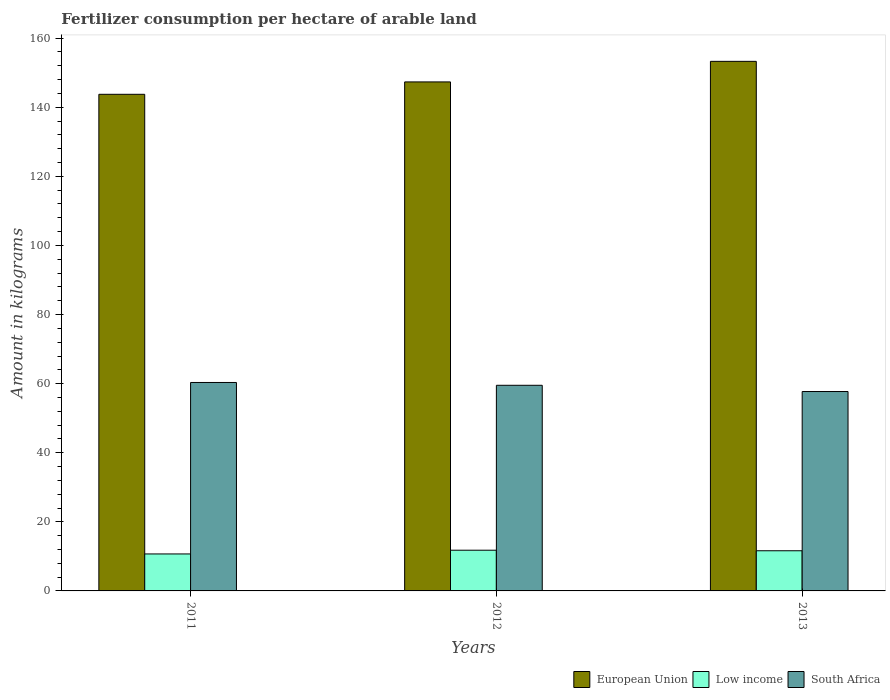Are the number of bars per tick equal to the number of legend labels?
Make the answer very short. Yes. Are the number of bars on each tick of the X-axis equal?
Offer a terse response. Yes. How many bars are there on the 1st tick from the left?
Provide a short and direct response. 3. How many bars are there on the 1st tick from the right?
Your response must be concise. 3. What is the label of the 2nd group of bars from the left?
Ensure brevity in your answer.  2012. In how many cases, is the number of bars for a given year not equal to the number of legend labels?
Ensure brevity in your answer.  0. What is the amount of fertilizer consumption in European Union in 2013?
Provide a short and direct response. 153.29. Across all years, what is the maximum amount of fertilizer consumption in Low income?
Offer a very short reply. 11.78. Across all years, what is the minimum amount of fertilizer consumption in South Africa?
Ensure brevity in your answer.  57.72. What is the total amount of fertilizer consumption in South Africa in the graph?
Keep it short and to the point. 177.58. What is the difference between the amount of fertilizer consumption in Low income in 2012 and that in 2013?
Your answer should be compact. 0.16. What is the difference between the amount of fertilizer consumption in Low income in 2012 and the amount of fertilizer consumption in European Union in 2013?
Give a very brief answer. -141.51. What is the average amount of fertilizer consumption in South Africa per year?
Your answer should be compact. 59.19. In the year 2011, what is the difference between the amount of fertilizer consumption in Low income and amount of fertilizer consumption in European Union?
Provide a short and direct response. -133.05. What is the ratio of the amount of fertilizer consumption in South Africa in 2011 to that in 2012?
Your response must be concise. 1.01. Is the difference between the amount of fertilizer consumption in Low income in 2011 and 2013 greater than the difference between the amount of fertilizer consumption in European Union in 2011 and 2013?
Keep it short and to the point. Yes. What is the difference between the highest and the second highest amount of fertilizer consumption in Low income?
Your answer should be very brief. 0.16. What is the difference between the highest and the lowest amount of fertilizer consumption in Low income?
Provide a short and direct response. 1.08. Is the sum of the amount of fertilizer consumption in European Union in 2011 and 2013 greater than the maximum amount of fertilizer consumption in Low income across all years?
Your answer should be very brief. Yes. What does the 2nd bar from the left in 2011 represents?
Offer a very short reply. Low income. What does the 1st bar from the right in 2012 represents?
Keep it short and to the point. South Africa. How many bars are there?
Give a very brief answer. 9. Are all the bars in the graph horizontal?
Ensure brevity in your answer.  No. What is the difference between two consecutive major ticks on the Y-axis?
Make the answer very short. 20. Where does the legend appear in the graph?
Ensure brevity in your answer.  Bottom right. What is the title of the graph?
Make the answer very short. Fertilizer consumption per hectare of arable land. What is the label or title of the X-axis?
Provide a succinct answer. Years. What is the label or title of the Y-axis?
Make the answer very short. Amount in kilograms. What is the Amount in kilograms of European Union in 2011?
Your response must be concise. 143.75. What is the Amount in kilograms in Low income in 2011?
Keep it short and to the point. 10.7. What is the Amount in kilograms of South Africa in 2011?
Your answer should be very brief. 60.34. What is the Amount in kilograms of European Union in 2012?
Your answer should be very brief. 147.34. What is the Amount in kilograms of Low income in 2012?
Your answer should be compact. 11.78. What is the Amount in kilograms of South Africa in 2012?
Offer a very short reply. 59.52. What is the Amount in kilograms in European Union in 2013?
Offer a terse response. 153.29. What is the Amount in kilograms in Low income in 2013?
Provide a short and direct response. 11.62. What is the Amount in kilograms of South Africa in 2013?
Provide a succinct answer. 57.72. Across all years, what is the maximum Amount in kilograms of European Union?
Your answer should be compact. 153.29. Across all years, what is the maximum Amount in kilograms in Low income?
Make the answer very short. 11.78. Across all years, what is the maximum Amount in kilograms of South Africa?
Make the answer very short. 60.34. Across all years, what is the minimum Amount in kilograms in European Union?
Offer a very short reply. 143.75. Across all years, what is the minimum Amount in kilograms of Low income?
Offer a terse response. 10.7. Across all years, what is the minimum Amount in kilograms in South Africa?
Make the answer very short. 57.72. What is the total Amount in kilograms in European Union in the graph?
Keep it short and to the point. 444.38. What is the total Amount in kilograms in Low income in the graph?
Provide a short and direct response. 34.11. What is the total Amount in kilograms in South Africa in the graph?
Offer a terse response. 177.58. What is the difference between the Amount in kilograms of European Union in 2011 and that in 2012?
Offer a terse response. -3.59. What is the difference between the Amount in kilograms of Low income in 2011 and that in 2012?
Give a very brief answer. -1.08. What is the difference between the Amount in kilograms of South Africa in 2011 and that in 2012?
Keep it short and to the point. 0.81. What is the difference between the Amount in kilograms in European Union in 2011 and that in 2013?
Give a very brief answer. -9.54. What is the difference between the Amount in kilograms of Low income in 2011 and that in 2013?
Give a very brief answer. -0.92. What is the difference between the Amount in kilograms in South Africa in 2011 and that in 2013?
Your response must be concise. 2.62. What is the difference between the Amount in kilograms of European Union in 2012 and that in 2013?
Your answer should be very brief. -5.95. What is the difference between the Amount in kilograms in Low income in 2012 and that in 2013?
Provide a short and direct response. 0.16. What is the difference between the Amount in kilograms in South Africa in 2012 and that in 2013?
Keep it short and to the point. 1.8. What is the difference between the Amount in kilograms of European Union in 2011 and the Amount in kilograms of Low income in 2012?
Ensure brevity in your answer.  131.97. What is the difference between the Amount in kilograms in European Union in 2011 and the Amount in kilograms in South Africa in 2012?
Keep it short and to the point. 84.23. What is the difference between the Amount in kilograms of Low income in 2011 and the Amount in kilograms of South Africa in 2012?
Make the answer very short. -48.82. What is the difference between the Amount in kilograms in European Union in 2011 and the Amount in kilograms in Low income in 2013?
Your answer should be compact. 132.13. What is the difference between the Amount in kilograms of European Union in 2011 and the Amount in kilograms of South Africa in 2013?
Give a very brief answer. 86.03. What is the difference between the Amount in kilograms in Low income in 2011 and the Amount in kilograms in South Africa in 2013?
Make the answer very short. -47.02. What is the difference between the Amount in kilograms of European Union in 2012 and the Amount in kilograms of Low income in 2013?
Make the answer very short. 135.71. What is the difference between the Amount in kilograms in European Union in 2012 and the Amount in kilograms in South Africa in 2013?
Offer a terse response. 89.62. What is the difference between the Amount in kilograms of Low income in 2012 and the Amount in kilograms of South Africa in 2013?
Provide a short and direct response. -45.94. What is the average Amount in kilograms in European Union per year?
Provide a succinct answer. 148.13. What is the average Amount in kilograms in Low income per year?
Make the answer very short. 11.37. What is the average Amount in kilograms of South Africa per year?
Offer a very short reply. 59.19. In the year 2011, what is the difference between the Amount in kilograms of European Union and Amount in kilograms of Low income?
Provide a succinct answer. 133.05. In the year 2011, what is the difference between the Amount in kilograms in European Union and Amount in kilograms in South Africa?
Your answer should be compact. 83.42. In the year 2011, what is the difference between the Amount in kilograms of Low income and Amount in kilograms of South Africa?
Provide a succinct answer. -49.64. In the year 2012, what is the difference between the Amount in kilograms of European Union and Amount in kilograms of Low income?
Offer a very short reply. 135.56. In the year 2012, what is the difference between the Amount in kilograms in European Union and Amount in kilograms in South Africa?
Give a very brief answer. 87.81. In the year 2012, what is the difference between the Amount in kilograms in Low income and Amount in kilograms in South Africa?
Provide a short and direct response. -47.74. In the year 2013, what is the difference between the Amount in kilograms of European Union and Amount in kilograms of Low income?
Offer a terse response. 141.67. In the year 2013, what is the difference between the Amount in kilograms of European Union and Amount in kilograms of South Africa?
Keep it short and to the point. 95.57. In the year 2013, what is the difference between the Amount in kilograms of Low income and Amount in kilograms of South Africa?
Keep it short and to the point. -46.09. What is the ratio of the Amount in kilograms in European Union in 2011 to that in 2012?
Give a very brief answer. 0.98. What is the ratio of the Amount in kilograms in Low income in 2011 to that in 2012?
Give a very brief answer. 0.91. What is the ratio of the Amount in kilograms of South Africa in 2011 to that in 2012?
Your answer should be very brief. 1.01. What is the ratio of the Amount in kilograms of European Union in 2011 to that in 2013?
Your answer should be compact. 0.94. What is the ratio of the Amount in kilograms of Low income in 2011 to that in 2013?
Your answer should be very brief. 0.92. What is the ratio of the Amount in kilograms in South Africa in 2011 to that in 2013?
Your answer should be compact. 1.05. What is the ratio of the Amount in kilograms in European Union in 2012 to that in 2013?
Offer a very short reply. 0.96. What is the ratio of the Amount in kilograms in Low income in 2012 to that in 2013?
Your answer should be compact. 1.01. What is the ratio of the Amount in kilograms of South Africa in 2012 to that in 2013?
Ensure brevity in your answer.  1.03. What is the difference between the highest and the second highest Amount in kilograms in European Union?
Make the answer very short. 5.95. What is the difference between the highest and the second highest Amount in kilograms in Low income?
Give a very brief answer. 0.16. What is the difference between the highest and the second highest Amount in kilograms of South Africa?
Your answer should be very brief. 0.81. What is the difference between the highest and the lowest Amount in kilograms in European Union?
Offer a very short reply. 9.54. What is the difference between the highest and the lowest Amount in kilograms of Low income?
Offer a terse response. 1.08. What is the difference between the highest and the lowest Amount in kilograms of South Africa?
Offer a very short reply. 2.62. 